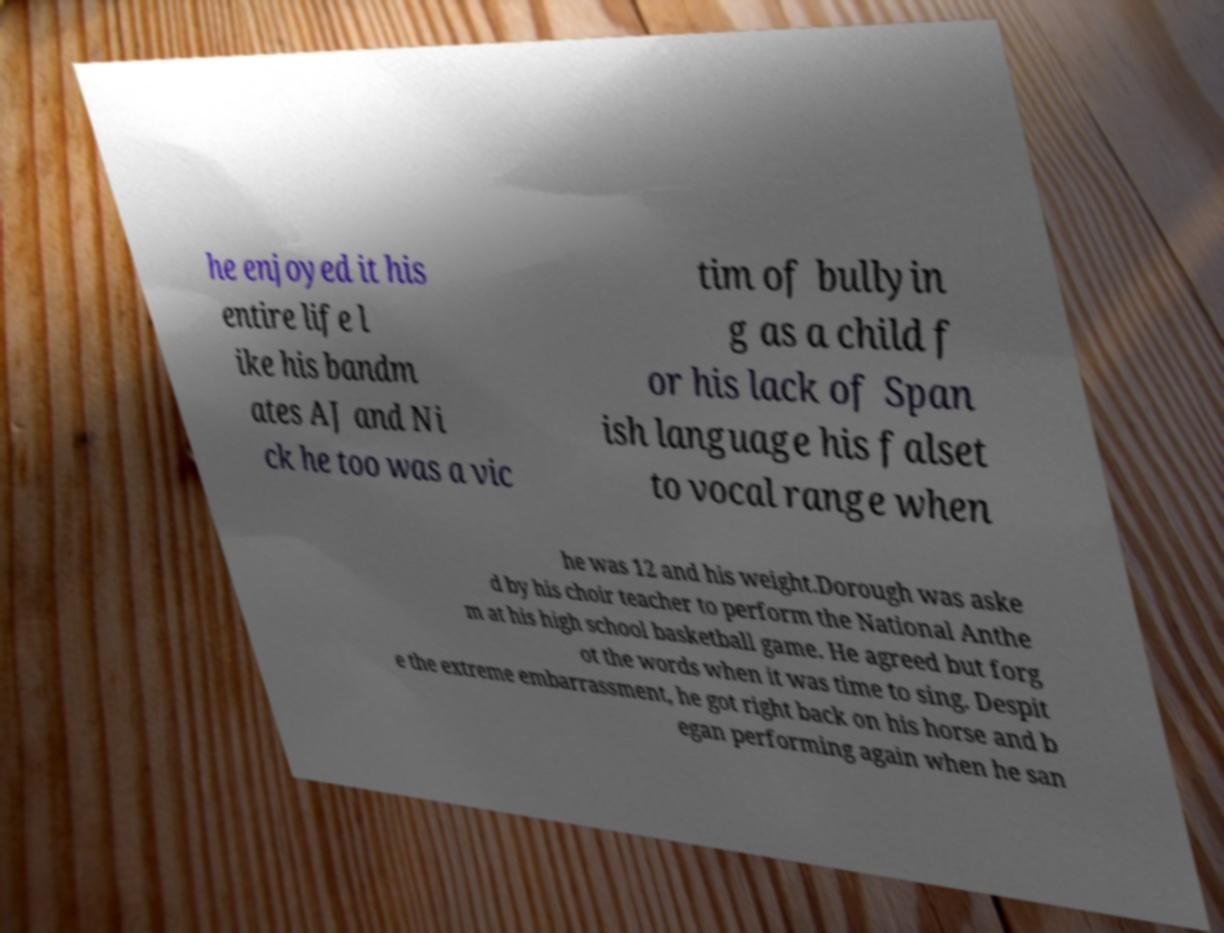For documentation purposes, I need the text within this image transcribed. Could you provide that? he enjoyed it his entire life l ike his bandm ates AJ and Ni ck he too was a vic tim of bullyin g as a child f or his lack of Span ish language his falset to vocal range when he was 12 and his weight.Dorough was aske d by his choir teacher to perform the National Anthe m at his high school basketball game. He agreed but forg ot the words when it was time to sing. Despit e the extreme embarrassment, he got right back on his horse and b egan performing again when he san 